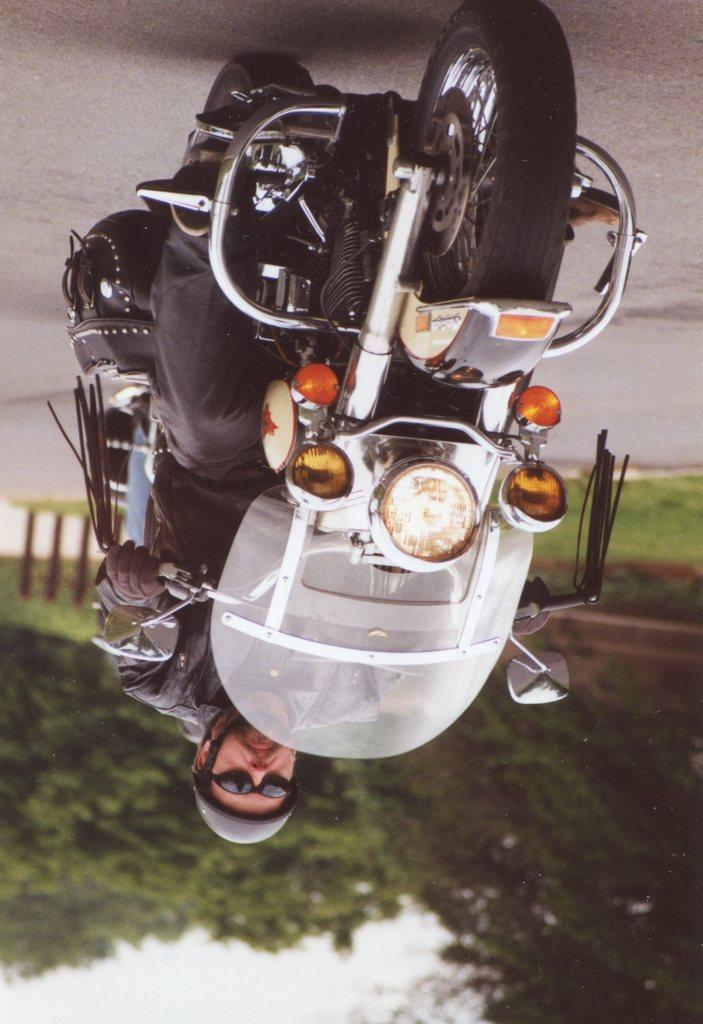How is the orientation of the image? The image is tilted. What can be seen at the bottom of the image? There are trees at the bottom of the image. What is located at the top of the image? There is a road at the top of the image. What activity is the man in the image engaged in? A man is riding a bike on the road. What type of vacation is the laborer taking in the image? There is no laborer present in the image, and no vacation is depicted. 